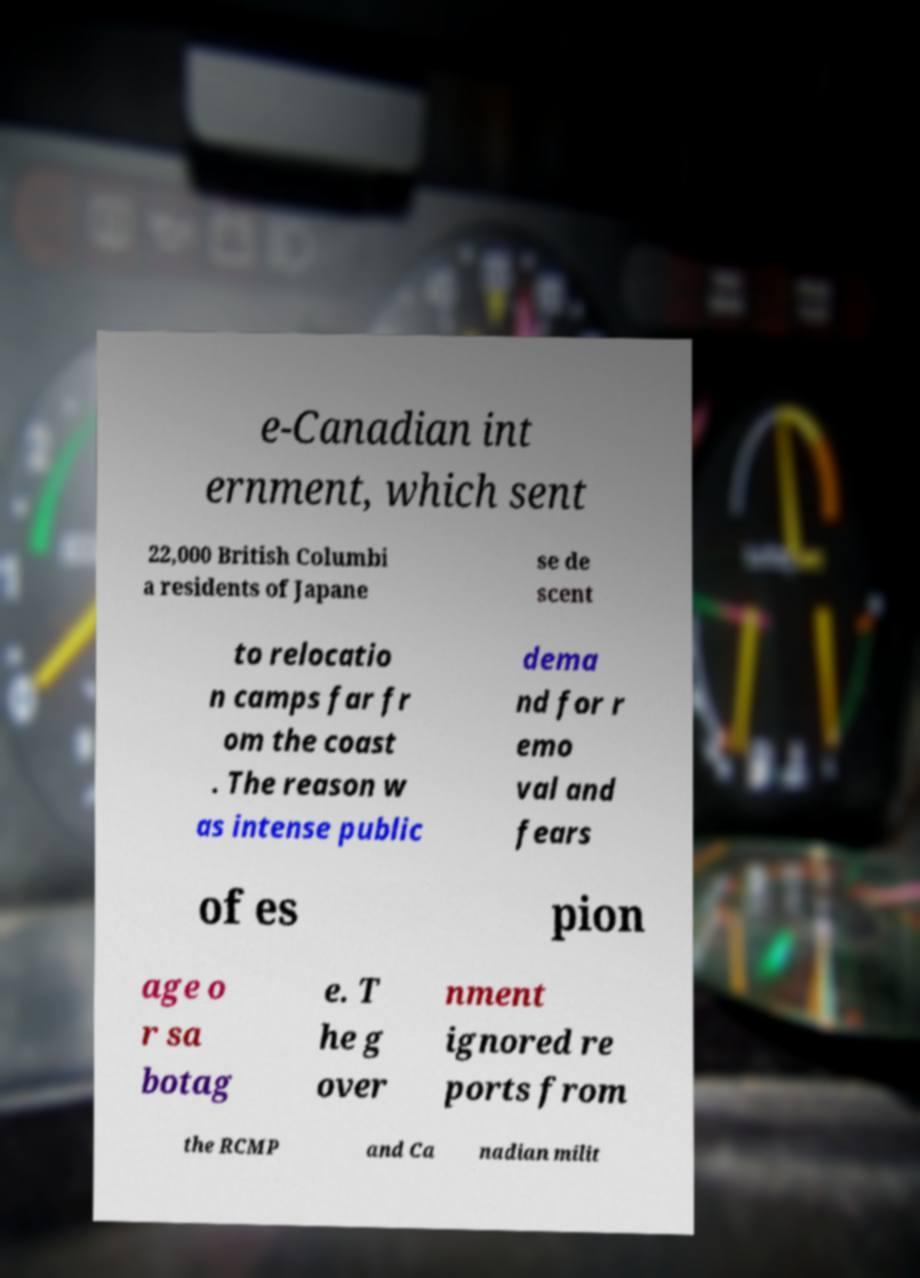For documentation purposes, I need the text within this image transcribed. Could you provide that? e-Canadian int ernment, which sent 22,000 British Columbi a residents of Japane se de scent to relocatio n camps far fr om the coast . The reason w as intense public dema nd for r emo val and fears of es pion age o r sa botag e. T he g over nment ignored re ports from the RCMP and Ca nadian milit 